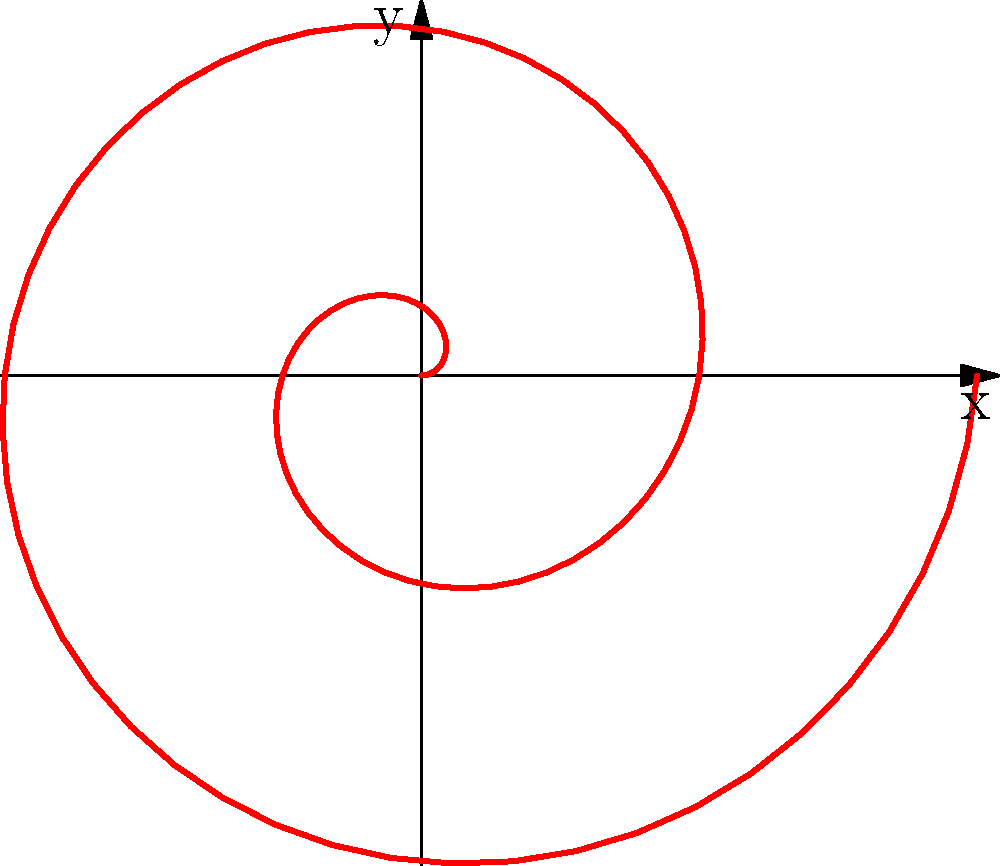As an online content creator showcasing math concepts, you're discussing polar coordinates. You've plotted a spiral pattern using the equation $r = 0.2\theta$. How many complete rotations does this spiral make around the origin? Let's approach this step-by-step:

1) In polar coordinates, one complete rotation corresponds to an angle of $2\pi$ radians.

2) The spiral is defined by the equation $r = 0.2\theta$, where $r$ is the radius and $\theta$ is the angle in radians.

3) Looking at the graph, we need to determine the maximum value of $\theta$ used to plot this spiral.

4) The spiral appears to end at a point where it has completed 2 full rotations.

5) To confirm this, we can check the maximum value of $\theta$ used in the Asymptote code:
   The code uses `polargraph(r,0,4pi)`, which means $\theta$ goes from 0 to $4\pi$.

6) $4\pi$ radians is equivalent to 2 complete rotations:
   $4\pi = 2 \cdot 2\pi$

Therefore, the spiral makes 2 complete rotations around the origin.
Answer: 2 rotations 